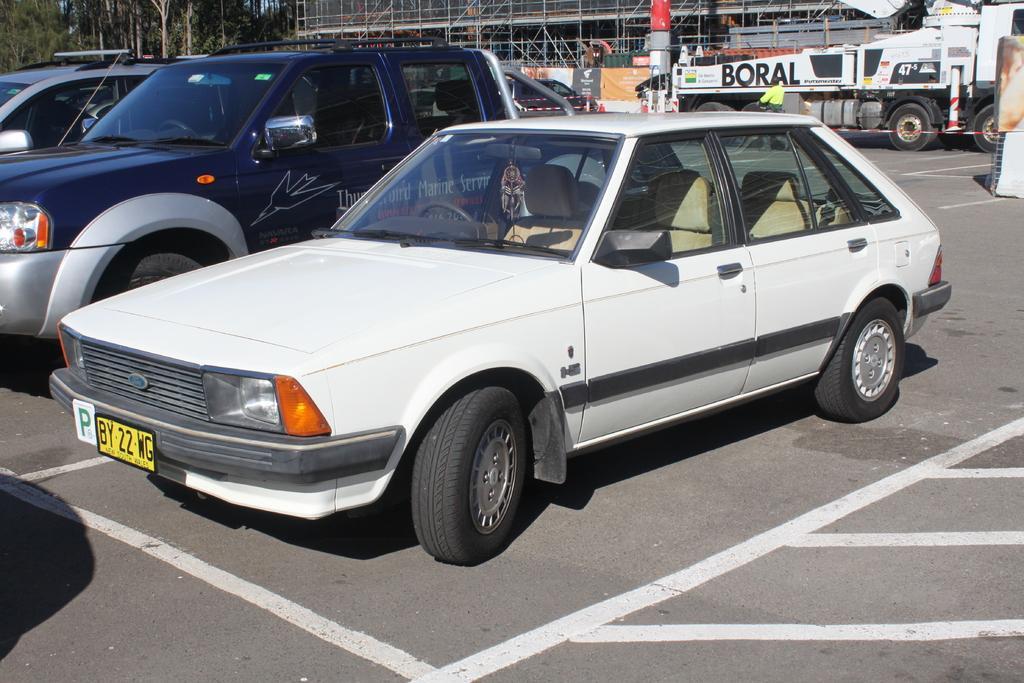Describe this image in one or two sentences. There are cars in the foreground area of the image, there are vehicles, a building structure, trees and the sky in the background. 